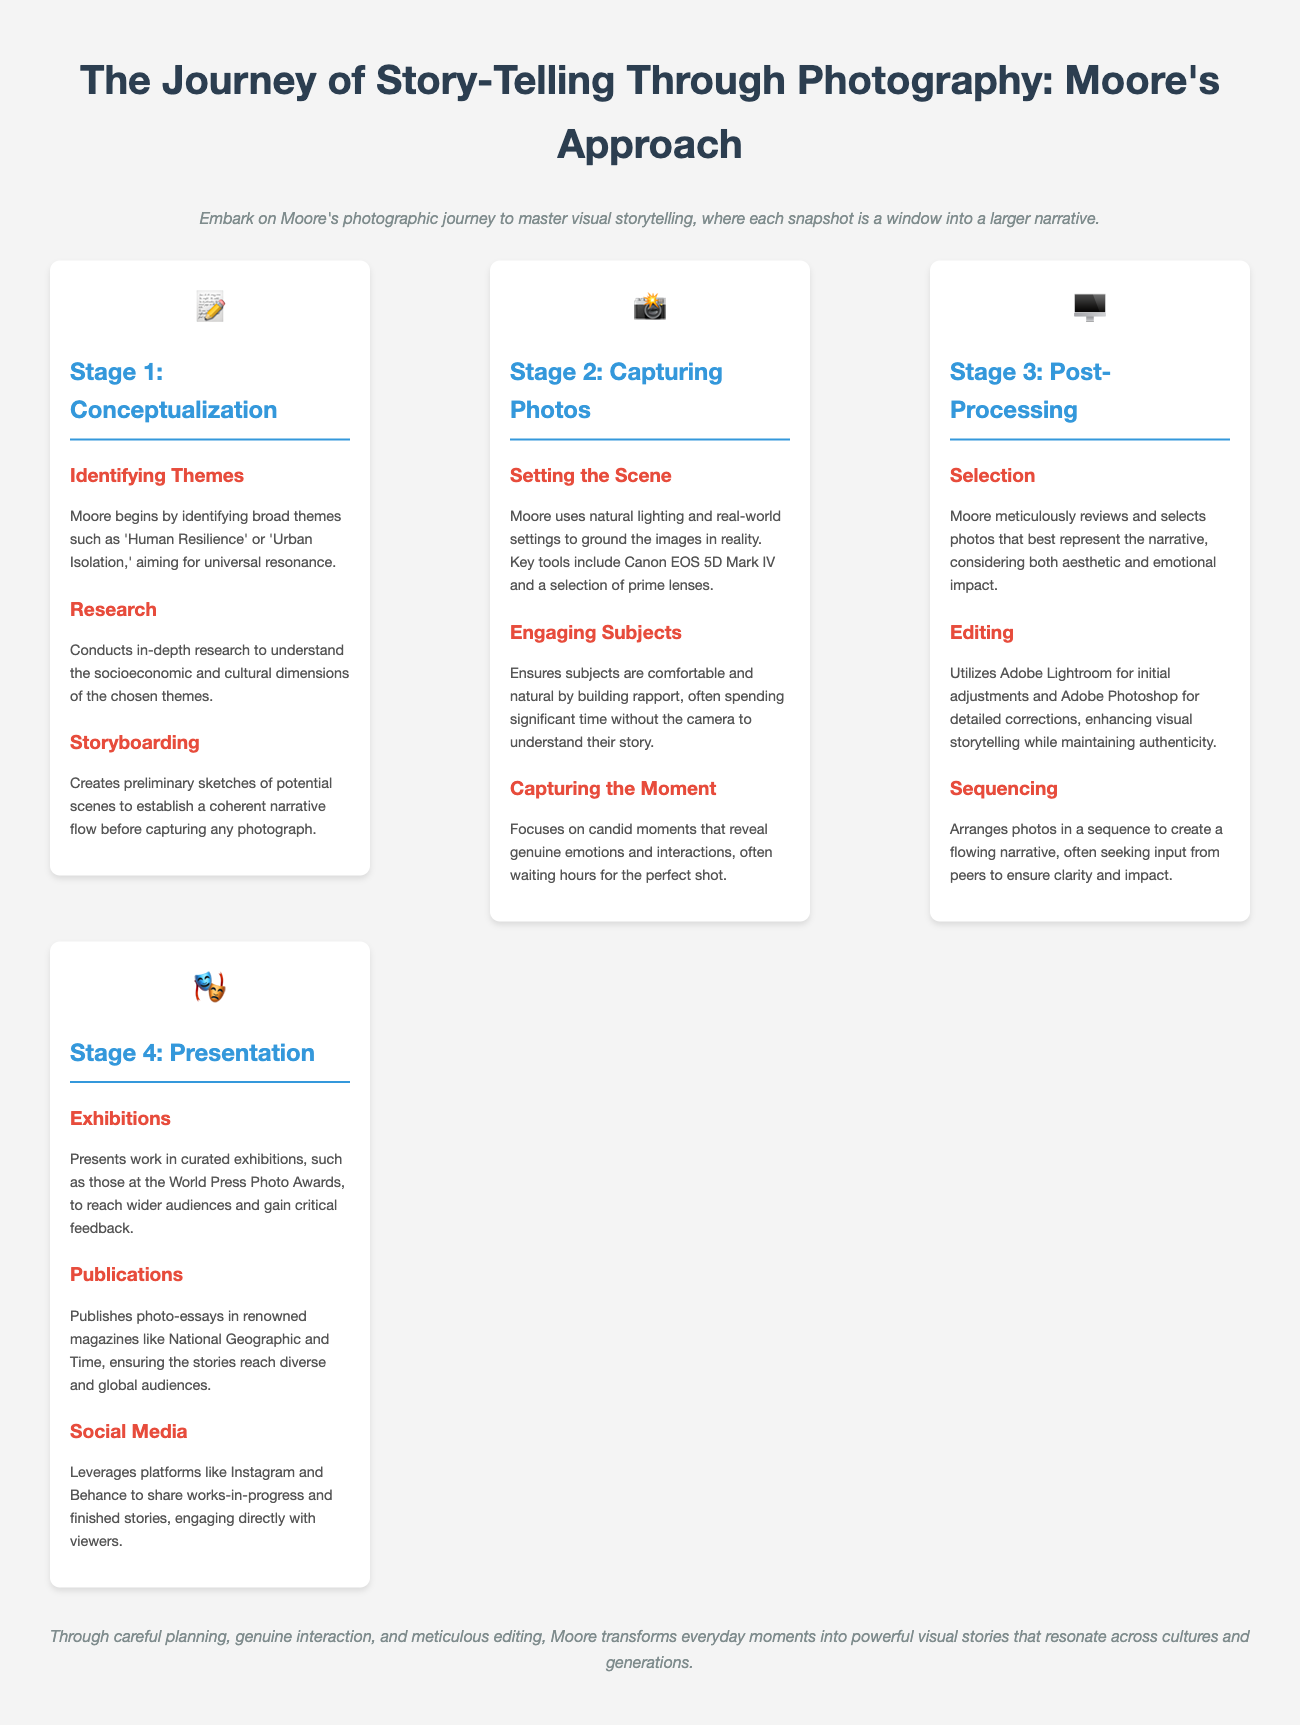what is the title of the infographic? The title is prominently displayed at the top of the document, summarizing the content.
Answer: The Journey of Story-Telling Through Photography: Moore's Approach what tool does Moore use for initial editing? The document specifies that Moore utilizes a specific software for the initial adjustments in post-processing.
Answer: Adobe Lightroom what themes does Moore identify in the conceptualization stage? The themes mentioned in the document highlight the focus of Moore's storytelling approach during the conceptualization stage.
Answer: Human Resilience, Urban Isolation how many stages are there in Moore's photographic journey? The infographic outlines distinct phases, each representing a part of the storytelling process.
Answer: Four what is the primary purpose of engaging subjects during the photo capture stage? The explanation provided in the document clarifies the intent behind this interaction with subjects.
Answer: To build rapport which platform does Moore leverage for sharing works-in-progress? The document mentions various platforms utilized for audience engagement in presenting photographic works.
Answer: Instagram what tool is specifically mentioned for detailed editing? The document specifies a tool used for more in-depth photo corrections in the post-processing stage.
Answer: Adobe Photoshop which event is mentioned for presenting work in exhibitions? The document references a notable event where Moore showcases his work to a broader audience.
Answer: World Press Photo Awards 